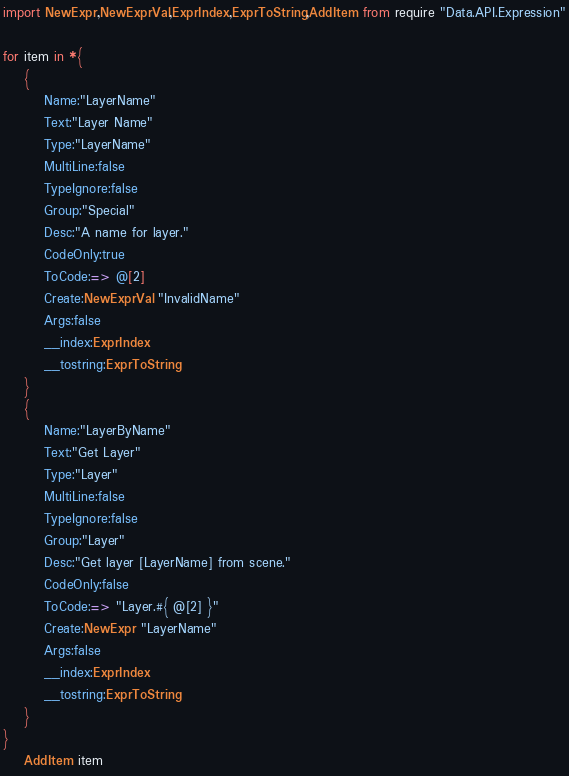Convert code to text. <code><loc_0><loc_0><loc_500><loc_500><_MoonScript_>import NewExpr,NewExprVal,ExprIndex,ExprToString,AddItem from require "Data.API.Expression"

for item in *{
	{
		Name:"LayerName"
		Text:"Layer Name"
		Type:"LayerName"
		MultiLine:false
		TypeIgnore:false
		Group:"Special"
		Desc:"A name for layer."
		CodeOnly:true
		ToCode:=> @[2]
		Create:NewExprVal "InvalidName"
		Args:false
		__index:ExprIndex
		__tostring:ExprToString
	}
	{
		Name:"LayerByName"
		Text:"Get Layer"
		Type:"Layer"
		MultiLine:false
		TypeIgnore:false
		Group:"Layer"
		Desc:"Get layer [LayerName] from scene."
		CodeOnly:false
		ToCode:=> "Layer.#{ @[2] }"
		Create:NewExpr "LayerName"
		Args:false
		__index:ExprIndex
		__tostring:ExprToString
	}
}
	AddItem item
</code> 